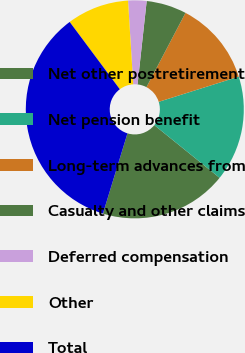<chart> <loc_0><loc_0><loc_500><loc_500><pie_chart><fcel>Net other postretirement<fcel>Net pension benefit<fcel>Long-term advances from<fcel>Casualty and other claims<fcel>Deferred compensation<fcel>Other<fcel>Total<nl><fcel>18.91%<fcel>15.67%<fcel>12.44%<fcel>5.96%<fcel>2.73%<fcel>9.2%<fcel>35.09%<nl></chart> 